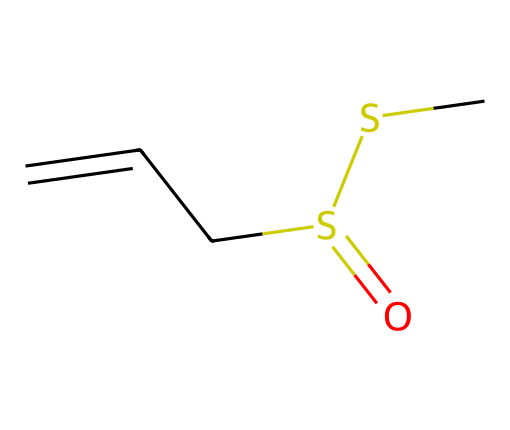what is the molecular formula of this compound? To determine the molecular formula, we count the number of each type of atom in the SMILES representation. The SMILES indicates there are 5 carbon (C) atoms, 8 hydrogen (H) atoms, 2 sulfur (S) atoms, and 1 oxygen (O) atom. Thus, the molecular formula is C5H8S2O.
Answer: C5H8S2O how many sulfur atoms are present in the structure? By inspecting the SMILES representation, we can see that the "S" appears twice. This indicates there are 2 sulfur atoms in the compound.
Answer: 2 what type of chemical compound is represented by this structure? The presence of sulfur and the specific arrangement of the atoms in the structure suggest it is a sulfur-containing organic compound derived from garlic. Allicin is classified as a sulfur compound.
Answer: sulfur compound how many double bonds are in the structure? In the SMILES, the "C=" notation indicates a double bond between carbon atoms. There is one occurrence of "C=" at the beginning of the structure and no other double bonds indicated. Therefore, there is one double bond in total.
Answer: 1 what are the functional groups present in this compound? Analyzing the SMILES, we identify a sulfoxide (due to the presence of sulfur bonded to oxygen) as well as a thioether (the S-C-S arrangement indicates this). Thus, the compound contains both sulfoxide and thioether functional groups.
Answer: sulfoxide and thioether which element significantly contributes to the characteristic odor of garlic? The sulfur atoms in this structure are primarily responsible for the pungent odor associated with garlic. The presence of the sulfur-containing functional groups is what leads to this characteristic smell.
Answer: sulfur 